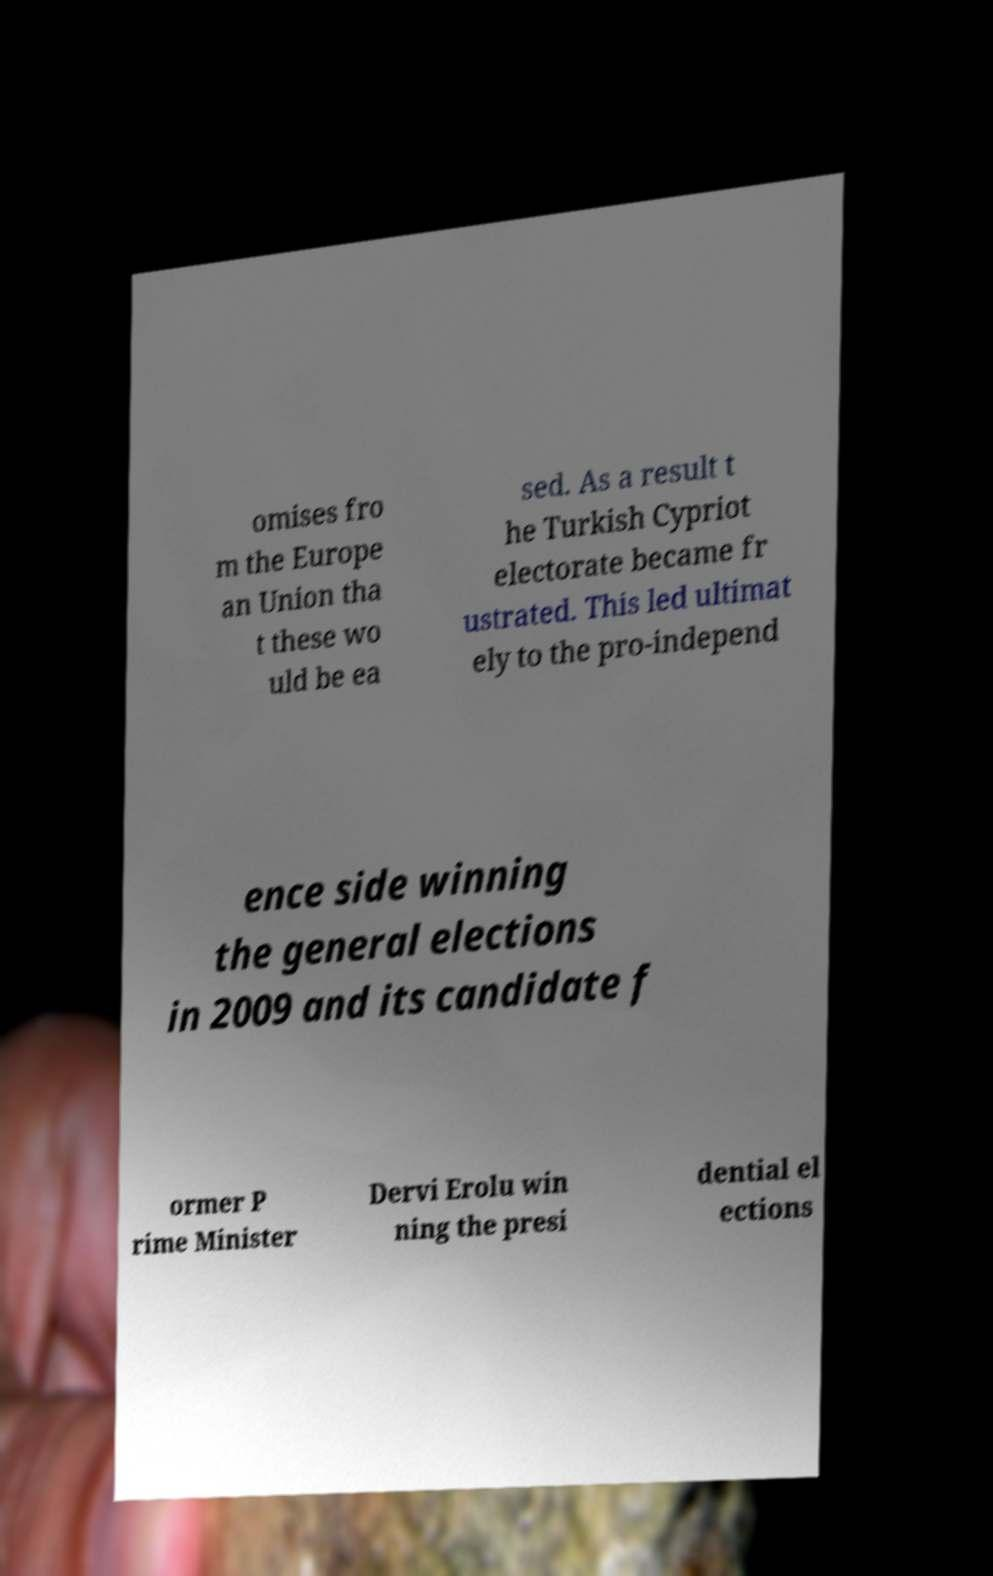I need the written content from this picture converted into text. Can you do that? omises fro m the Europe an Union tha t these wo uld be ea sed. As a result t he Turkish Cypriot electorate became fr ustrated. This led ultimat ely to the pro-independ ence side winning the general elections in 2009 and its candidate f ormer P rime Minister Dervi Erolu win ning the presi dential el ections 